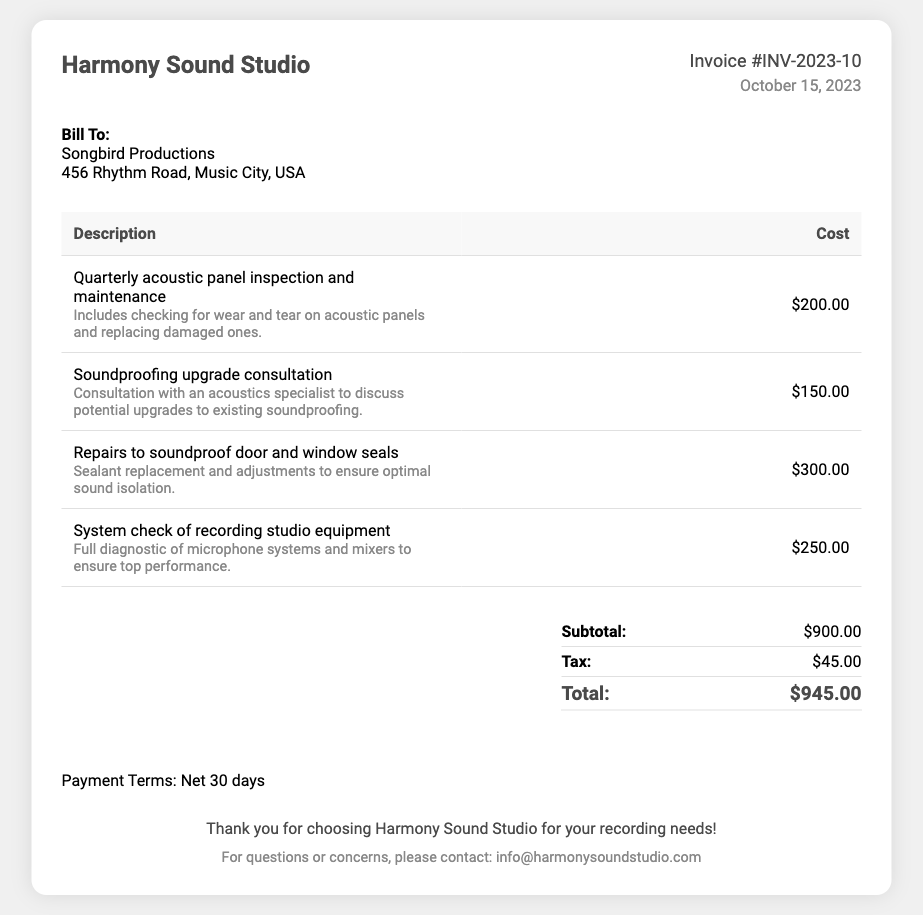What is the invoice number? The invoice number is a unique identifier for the bill provided in the document, which is indicated as #INV-2023-10.
Answer: #INV-2023-10 Who is the bill addressed to? The "Bill To" section includes the name and address of the client, which is Songbird Productions, located at 456 Rhythm Road, Music City, USA.
Answer: Songbird Productions What is the total amount due? The total amount due is calculated by adding the subtotal and tax listed in the document, which results in $900.00 + $45.00 = $945.00.
Answer: $945.00 When was the invoice issued? The date of invoice issuance is provided in the document, which is specified as October 15, 2023.
Answer: October 15, 2023 What is included in the quarterly acoustic panel inspection? The description includes checking for wear and tear on acoustic panels and replacing damaged ones, which provides insight into the service rendered.
Answer: Checking for wear and tear on acoustic panels and replacing damaged ones What is the subtotal for the services? The subtotal represents the sum of all service costs listed before tax, which is provided in the document as $900.00.
Answer: $900.00 What type of maintenance service is included for the soundproof door? The document lists the service related to soundproof door maintenance as sealant replacement and adjustments to ensure optimal sound isolation.
Answer: Sealant replacement and adjustments What are the payment terms stated in the document? The payment terms are defined as a period after which the payment is expected, specified as Net 30 days in the document.
Answer: Net 30 days Who should be contacted for questions or concerns? The footer contains contact information for inquiries, which lists the email address for customer questions as info@harmonysoundstudio.com.
Answer: info@harmonysoundstudio.com 